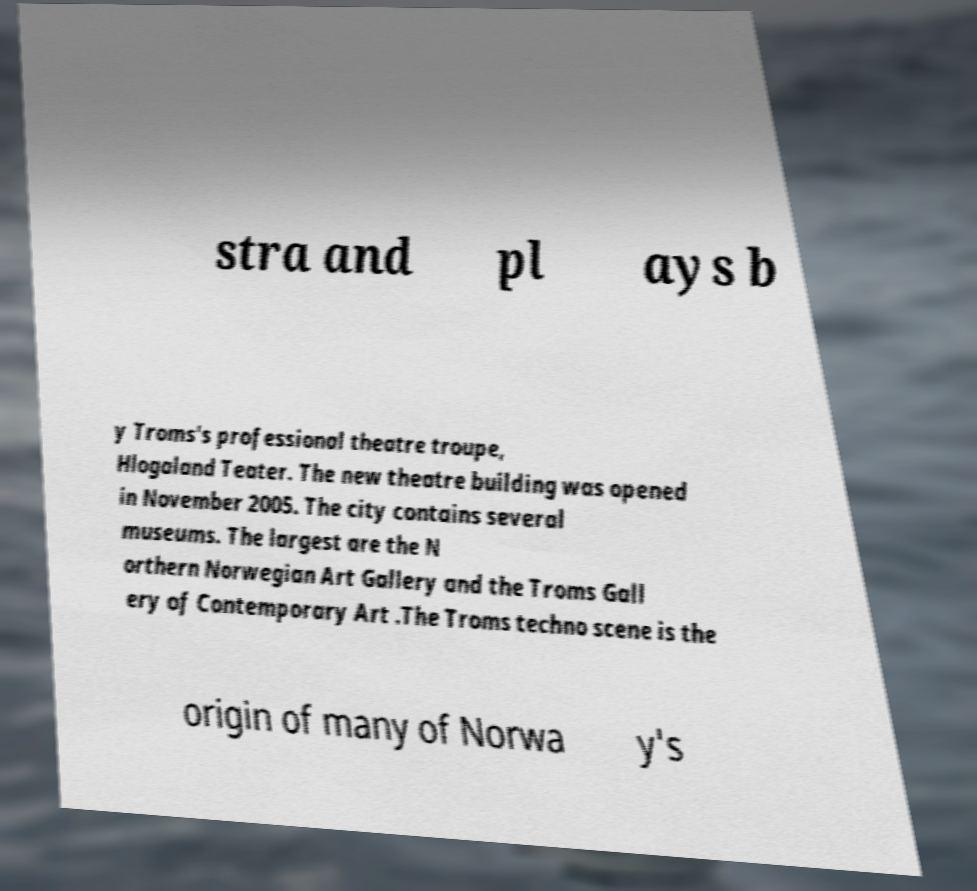Please identify and transcribe the text found in this image. stra and pl ays b y Troms's professional theatre troupe, Hlogaland Teater. The new theatre building was opened in November 2005. The city contains several museums. The largest are the N orthern Norwegian Art Gallery and the Troms Gall ery of Contemporary Art .The Troms techno scene is the origin of many of Norwa y's 